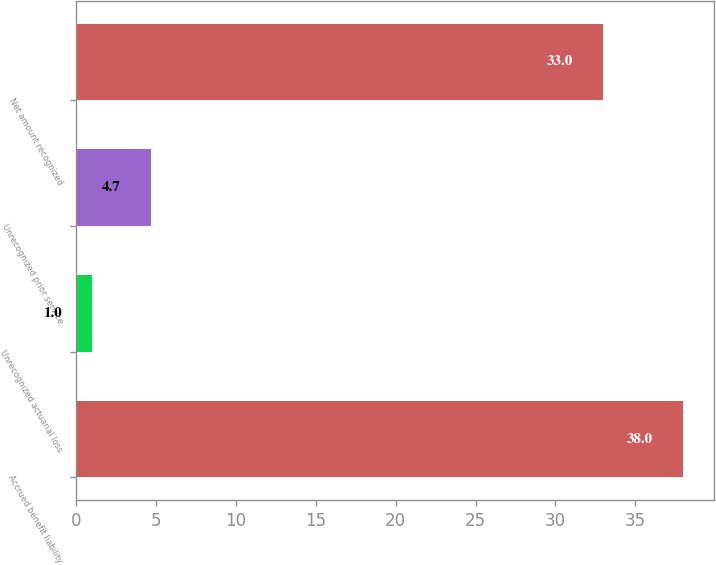<chart> <loc_0><loc_0><loc_500><loc_500><bar_chart><fcel>Accrued benefit liability<fcel>Unrecognized actuarial loss<fcel>Unrecognized prior service<fcel>Net amount recognized<nl><fcel>38<fcel>1<fcel>4.7<fcel>33<nl></chart> 